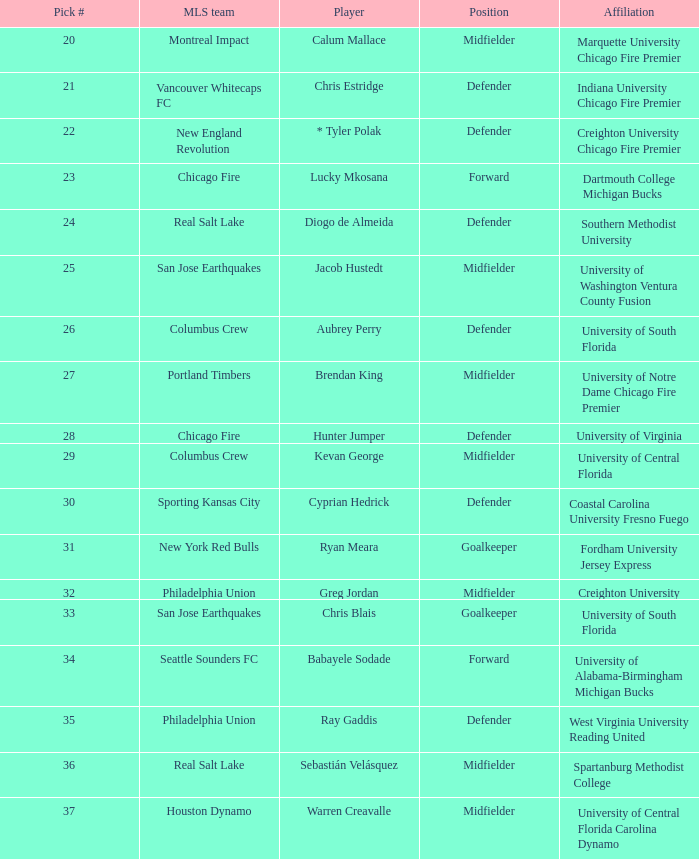I'm looking to parse the entire table for insights. Could you assist me with that? {'header': ['Pick #', 'MLS team', 'Player', 'Position', 'Affiliation'], 'rows': [['20', 'Montreal Impact', 'Calum Mallace', 'Midfielder', 'Marquette University Chicago Fire Premier'], ['21', 'Vancouver Whitecaps FC', 'Chris Estridge', 'Defender', 'Indiana University Chicago Fire Premier'], ['22', 'New England Revolution', '* Tyler Polak', 'Defender', 'Creighton University Chicago Fire Premier'], ['23', 'Chicago Fire', 'Lucky Mkosana', 'Forward', 'Dartmouth College Michigan Bucks'], ['24', 'Real Salt Lake', 'Diogo de Almeida', 'Defender', 'Southern Methodist University'], ['25', 'San Jose Earthquakes', 'Jacob Hustedt', 'Midfielder', 'University of Washington Ventura County Fusion'], ['26', 'Columbus Crew', 'Aubrey Perry', 'Defender', 'University of South Florida'], ['27', 'Portland Timbers', 'Brendan King', 'Midfielder', 'University of Notre Dame Chicago Fire Premier'], ['28', 'Chicago Fire', 'Hunter Jumper', 'Defender', 'University of Virginia'], ['29', 'Columbus Crew', 'Kevan George', 'Midfielder', 'University of Central Florida'], ['30', 'Sporting Kansas City', 'Cyprian Hedrick', 'Defender', 'Coastal Carolina University Fresno Fuego'], ['31', 'New York Red Bulls', 'Ryan Meara', 'Goalkeeper', 'Fordham University Jersey Express'], ['32', 'Philadelphia Union', 'Greg Jordan', 'Midfielder', 'Creighton University'], ['33', 'San Jose Earthquakes', 'Chris Blais', 'Goalkeeper', 'University of South Florida'], ['34', 'Seattle Sounders FC', 'Babayele Sodade', 'Forward', 'University of Alabama-Birmingham Michigan Bucks'], ['35', 'Philadelphia Union', 'Ray Gaddis', 'Defender', 'West Virginia University Reading United'], ['36', 'Real Salt Lake', 'Sebastián Velásquez', 'Midfielder', 'Spartanburg Methodist College'], ['37', 'Houston Dynamo', 'Warren Creavalle', 'Midfielder', 'University of Central Florida Carolina Dynamo']]} What pick number is Kevan George? 29.0. 